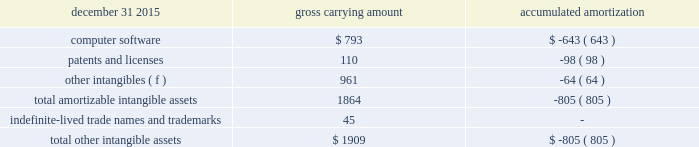December 31 , 2015 carrying amount accumulated amortization .
Computer software consists primarily of software costs associated with an enterprise business solution ( ebs ) within arconic to drive common systems among all businesses .
Amortization expense related to the intangible assets in the tables above for the years ended december 31 , 2016 , 2015 , and 2014 was $ 65 , $ 67 , and $ 55 , respectively , and is expected to be in the range of approximately $ 56 to $ 64 annually from 2017 to 2021 .
Acquisitions and divestitures pro forma results of the company , assuming all acquisitions described below were made at the beginning of the earliest prior period presented , would not have been materially different from the results reported .
2016 divestitures .
In april 2016 , arconic completed the sale of the remmele medical business to lisi medical for $ 102 in cash ( $ 99 net of transaction costs ) , which was included in proceeds from the sale of assets and businesses on the accompanying statement of consolidated cash flows .
This business , which was part of the rti international metals inc .
( rti ) acquisition ( see below ) , manufactures precision-machined metal products for customers in the minimally invasive surgical device and implantable device markets .
Since this transaction occurred within a year of the completion of the rti acquisition , no gain was recorded on this transaction as the excess of the proceeds over the carrying value of the net assets of this business was reflected as a purchase price adjustment ( decrease to goodwill of $ 44 ) to the final allocation of the purchase price related to arconic 2019s acquisition of rti .
While owned by arconic , the operating results and assets and liabilities of this business were included in the engineered products and solutions segment .
This business generated sales of approximately $ 20 from january 1 , 2016 through the divestiture date , april 29 , 2016 , and , at the time of the divestiture , had approximately 330 employees .
This transaction is no longer subject to post-closing adjustments .
2015 acquisitions .
In march 2015 , arconic completed the acquisition of an aerospace structural castings company , tital , for $ 204 ( 20ac188 ) in cash ( an additional $ 1 ( 20ac1 ) was paid in september 2015 to settle working capital in accordance with the purchase agreement ) .
Tital , a privately held company with approximately 650 employees based in germany , produces aluminum and titanium investment casting products for the aerospace and defense markets .
The purpose of this acquisition is to capture increasing demand for advanced jet engine components made of titanium , establish titanium-casting capabilities in europe , and expand existing aluminum casting capacity .
The assets , including the associated goodwill , and liabilities of this business were included within arconic 2019s engineered products and solutions segment since the date of acquisition .
Based on the preliminary allocation of the purchase price , goodwill of $ 118 was recorded for this transaction .
In the first quarter of 2016 , the allocation of the purchase price was finalized , based , in part , on the completion of a third-party valuation of certain assets acquired , resulting in a $ 1 reduction of the initial goodwill amount .
None of the $ 117 in goodwill is deductible for income tax purposes and no other intangible assets were identified .
This transaction is no longer subject to post-closing adjustments .
In july 2015 , arconic completed the acquisition of rti , a u.s .
Company that was publicly traded on the new york stock exchange under the ticker symbol 201crti . 201d arconic purchased all outstanding shares of rti common stock in a stock-for-stock transaction valued at $ 870 ( based on the $ 9.96 per share july 23 , 2015 closing price of arconic 2019s .
What is the original value of computer software , in dollars? 
Rationale: the original value is calculated based upon the gross carrying amount formula , in which the carrying amount is equal to the original value mines the amortization/depreciation costs .
Computations: (793 + 643)
Answer: 1436.0. 